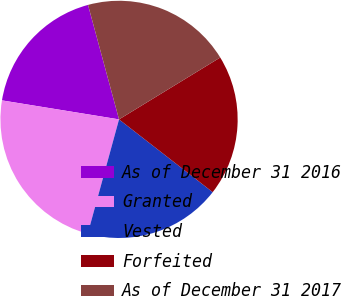<chart> <loc_0><loc_0><loc_500><loc_500><pie_chart><fcel>As of December 31 2016<fcel>Granted<fcel>Vested<fcel>Forfeited<fcel>As of December 31 2017<nl><fcel>18.23%<fcel>23.31%<fcel>18.74%<fcel>19.25%<fcel>20.48%<nl></chart> 